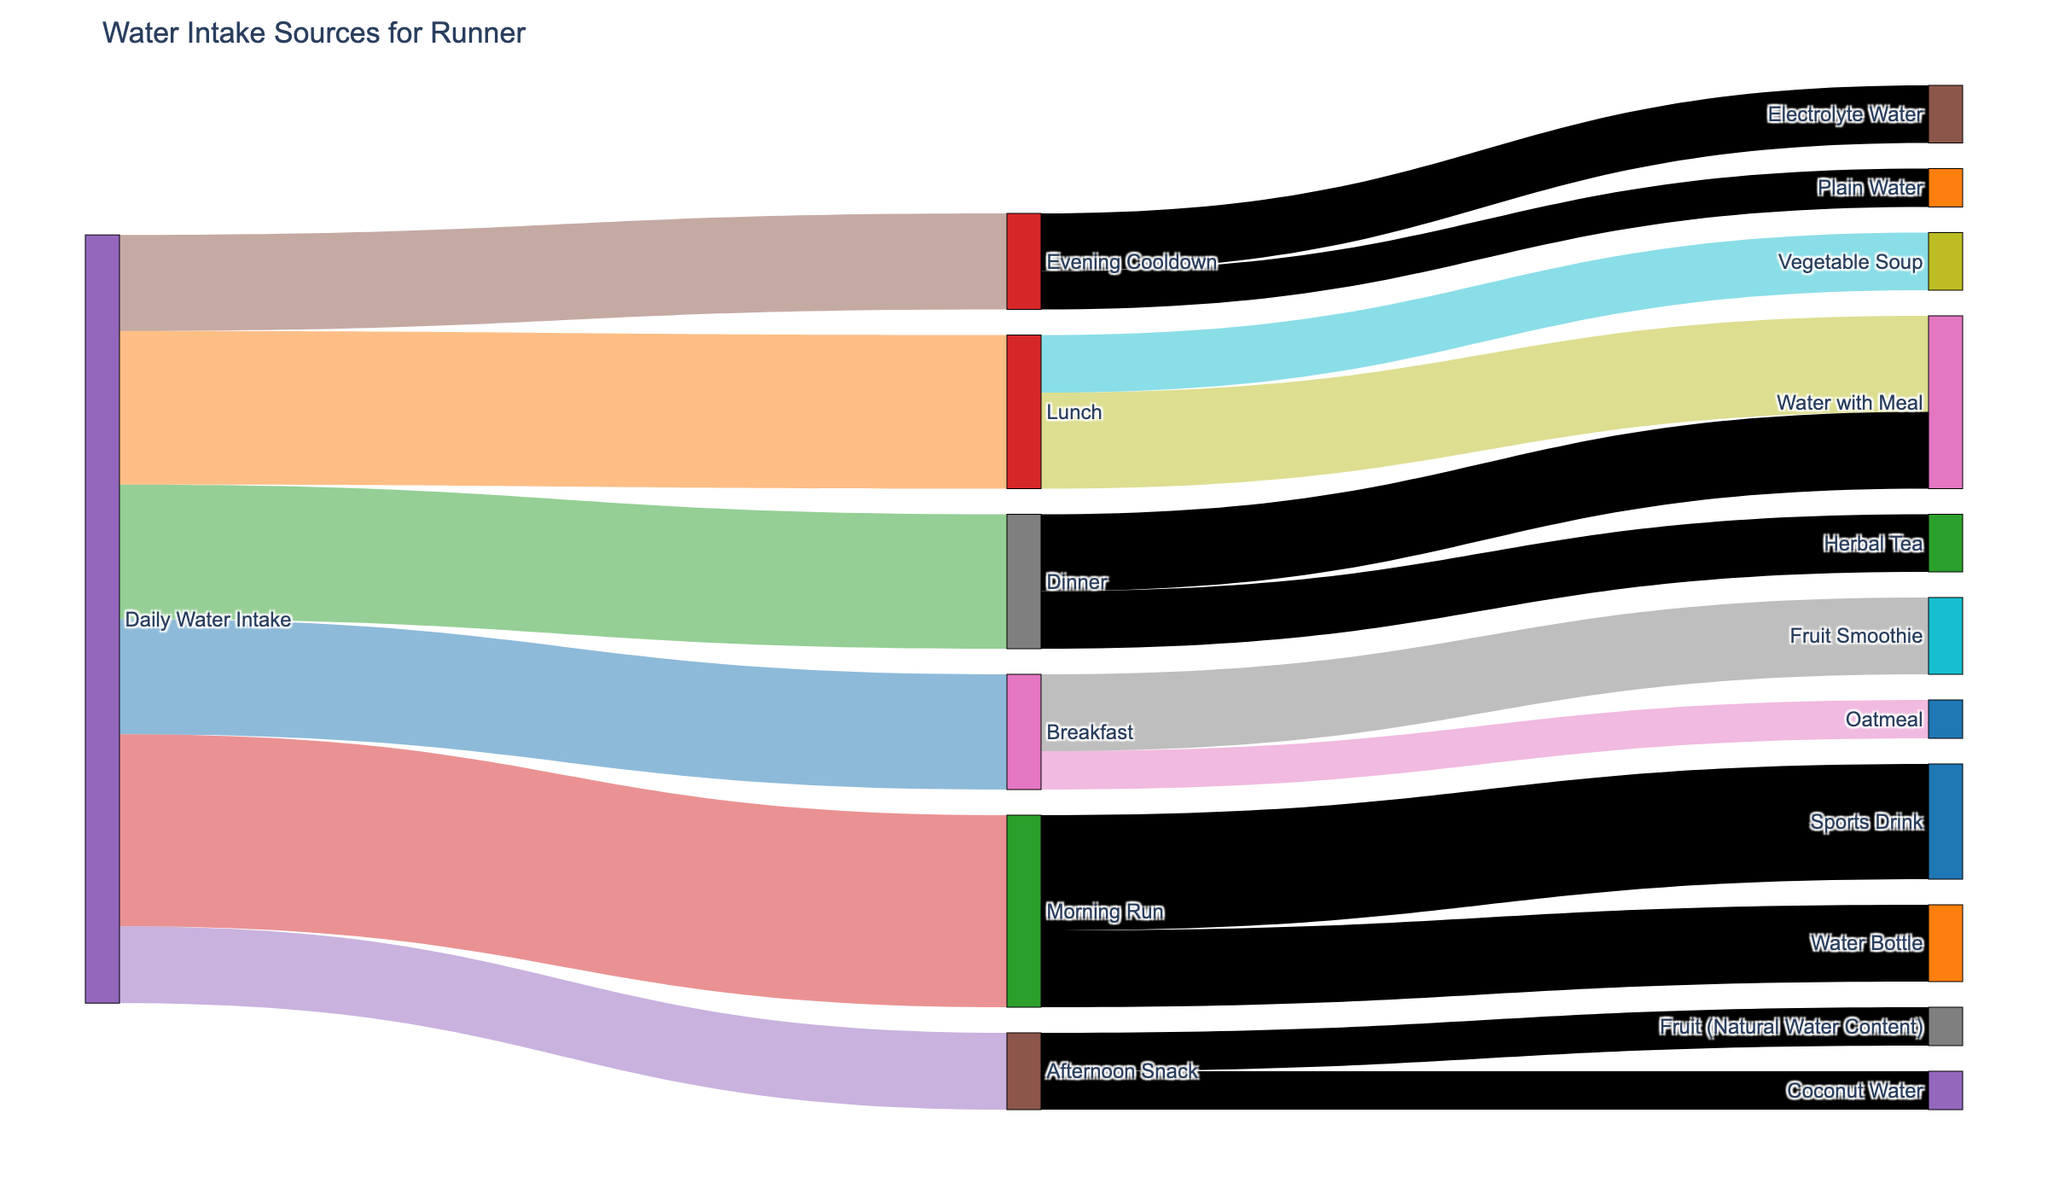Which meal contributes the most to water intake? To find which meal contributes the most to water intake, look at the figure and compare the values for Breakfast (300 ml), Lunch (400 ml), and Dinner (350 ml). Lunch has the highest value.
Answer: Lunch What is the total water intake from meals (Breakfast, Lunch, Dinner)? Sum the water intake values from Breakfast (300 ml), Lunch (400 ml), and Dinner (350 ml). The total is 300 + 400 + 350 = 1050 ml.
Answer: 1050 ml Which source provides more water: Morning Run or Evening Cooldown? Compare the water intake from Morning Run (500 ml) and Evening Cooldown (250 ml). Morning Run has a higher value.
Answer: Morning Run How much water is consumed during the Afternoon Snack? Look at the water intake associated with the Afternoon Snack, which sums to 100 ml (Coconut Water) + 100 ml (Fruit) = 200 ml.
Answer: 200 ml Which specific activity or source contributes the most to the total water intake? By comparing all the sources and activities, Morning Run with 500 ml is the highest individual contributor.
Answer: Morning Run What is the total daily water intake from all sources illustrated in the figure? Sum all the water intake values: 300 + 400 + 350 + 500 + 200 + 250 = 2000 ml.
Answer: 2000 ml How does the water intake from Dinner compare to Breakfast? Compare the values of Dinner (350 ml) and Breakfast (300 ml). Dinner contributes more water than Breakfast.
Answer: Dinner Which has a higher water intake: Water Bottle during Morning Run or Coconut Water during Afternoon Snack? Compare Water Bottle (200 ml) and Coconut Water (100 ml). Water Bottle has higher water intake.
Answer: Water Bottle What is the total water intake from all hydration periods (Morning Run, Afternoon Snack, Evening Cooldown) combined? Sum the water intake from Morning Run (500 ml), Afternoon Snack (200 ml), and Evening Cooldown (250 ml). The total is 500 + 200 + 250 = 950 ml.
Answer: 950 ml 